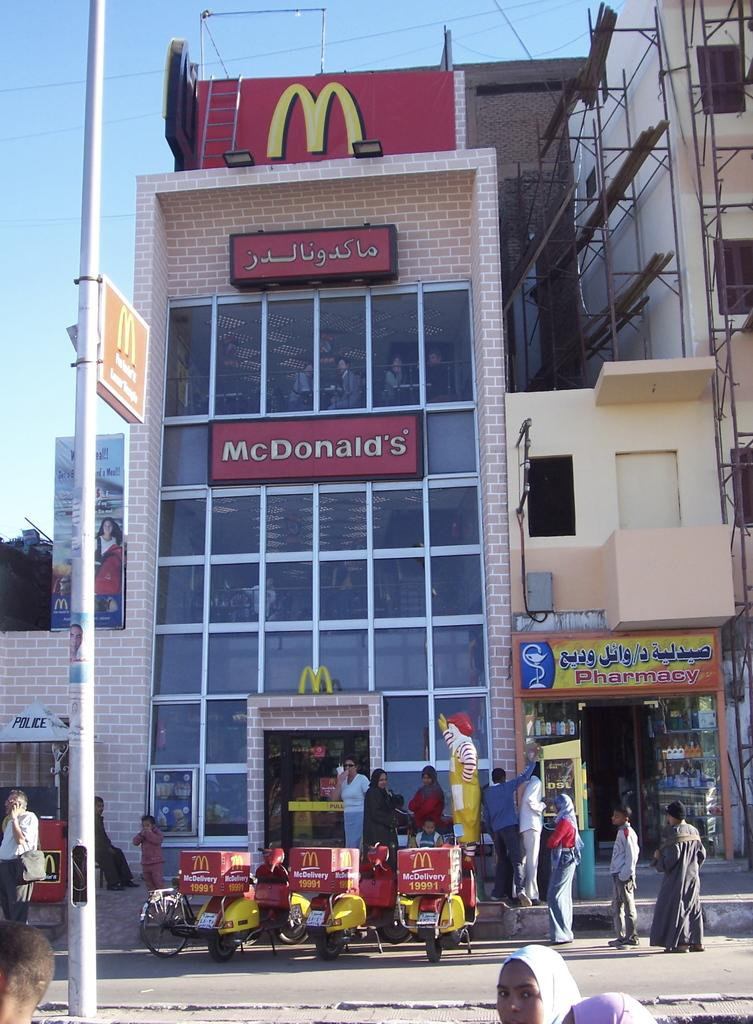<image>
Write a terse but informative summary of the picture. a multi storied McDonald's restaurant next to a Pharmacy 